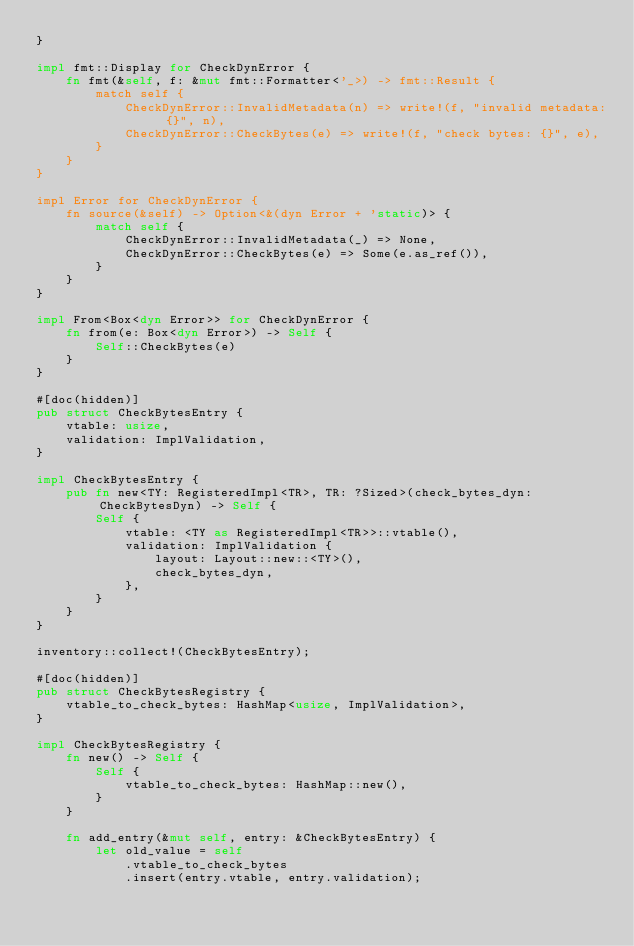Convert code to text. <code><loc_0><loc_0><loc_500><loc_500><_Rust_>}

impl fmt::Display for CheckDynError {
    fn fmt(&self, f: &mut fmt::Formatter<'_>) -> fmt::Result {
        match self {
            CheckDynError::InvalidMetadata(n) => write!(f, "invalid metadata: {}", n),
            CheckDynError::CheckBytes(e) => write!(f, "check bytes: {}", e),
        }
    }
}

impl Error for CheckDynError {
    fn source(&self) -> Option<&(dyn Error + 'static)> {
        match self {
            CheckDynError::InvalidMetadata(_) => None,
            CheckDynError::CheckBytes(e) => Some(e.as_ref()),
        }
    }
}

impl From<Box<dyn Error>> for CheckDynError {
    fn from(e: Box<dyn Error>) -> Self {
        Self::CheckBytes(e)
    }
}

#[doc(hidden)]
pub struct CheckBytesEntry {
    vtable: usize,
    validation: ImplValidation,
}

impl CheckBytesEntry {
    pub fn new<TY: RegisteredImpl<TR>, TR: ?Sized>(check_bytes_dyn: CheckBytesDyn) -> Self {
        Self {
            vtable: <TY as RegisteredImpl<TR>>::vtable(),
            validation: ImplValidation {
                layout: Layout::new::<TY>(),
                check_bytes_dyn,
            },
        }
    }
}

inventory::collect!(CheckBytesEntry);

#[doc(hidden)]
pub struct CheckBytesRegistry {
    vtable_to_check_bytes: HashMap<usize, ImplValidation>,
}

impl CheckBytesRegistry {
    fn new() -> Self {
        Self {
            vtable_to_check_bytes: HashMap::new(),
        }
    }

    fn add_entry(&mut self, entry: &CheckBytesEntry) {
        let old_value = self
            .vtable_to_check_bytes
            .insert(entry.vtable, entry.validation);
</code> 